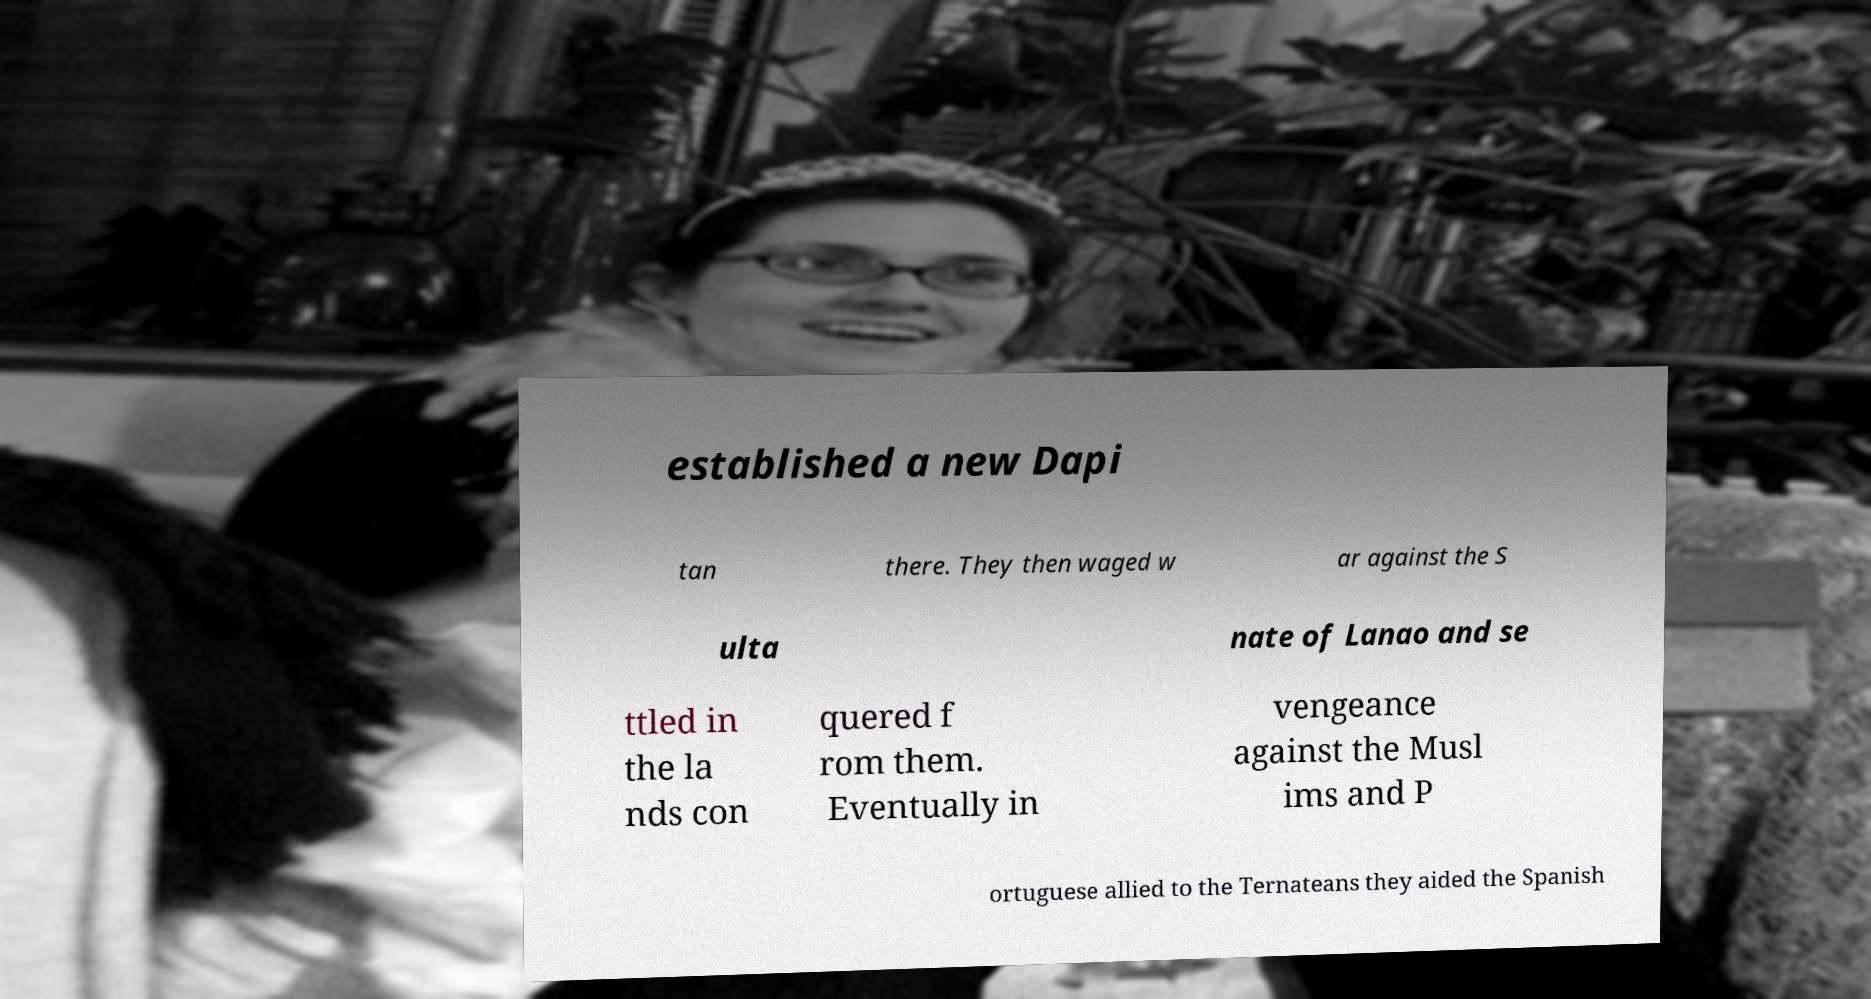Please identify and transcribe the text found in this image. established a new Dapi tan there. They then waged w ar against the S ulta nate of Lanao and se ttled in the la nds con quered f rom them. Eventually in vengeance against the Musl ims and P ortuguese allied to the Ternateans they aided the Spanish 